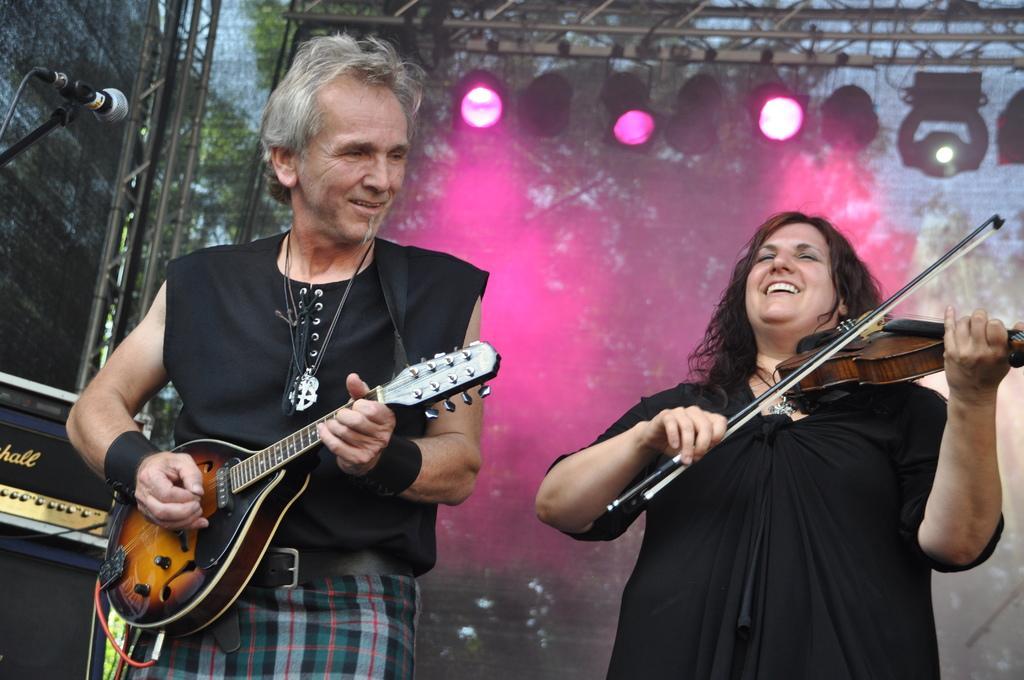In one or two sentences, can you explain what this image depicts? This image is clicked in a musical concert. There are lights on the top and trees in the back side. There are two persons standing. Both of them are wearing black dress. They are playing two musical instruments. There is a mic on the left side top corner, there is a net behind them. 